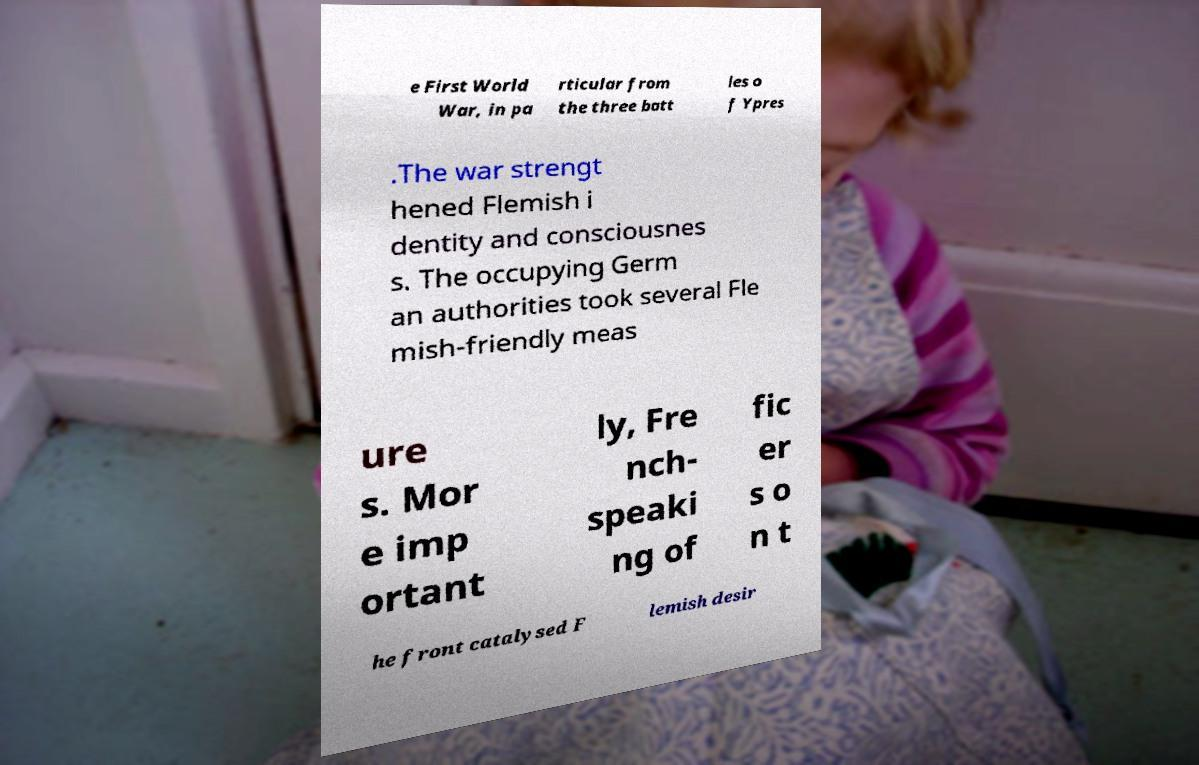For documentation purposes, I need the text within this image transcribed. Could you provide that? e First World War, in pa rticular from the three batt les o f Ypres .The war strengt hened Flemish i dentity and consciousnes s. The occupying Germ an authorities took several Fle mish-friendly meas ure s. Mor e imp ortant ly, Fre nch- speaki ng of fic er s o n t he front catalysed F lemish desir 